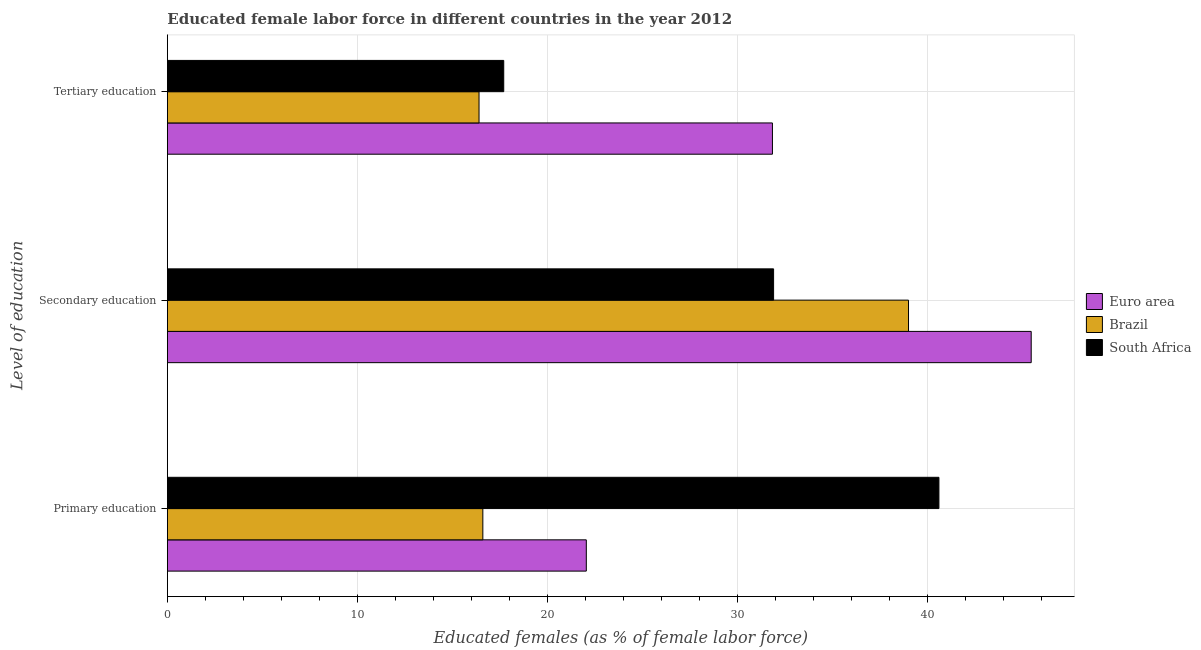How many different coloured bars are there?
Provide a short and direct response. 3. What is the label of the 2nd group of bars from the top?
Offer a very short reply. Secondary education. What is the percentage of female labor force who received tertiary education in South Africa?
Provide a short and direct response. 17.7. Across all countries, what is the maximum percentage of female labor force who received tertiary education?
Ensure brevity in your answer.  31.84. Across all countries, what is the minimum percentage of female labor force who received primary education?
Keep it short and to the point. 16.6. In which country was the percentage of female labor force who received primary education maximum?
Provide a succinct answer. South Africa. In which country was the percentage of female labor force who received primary education minimum?
Provide a short and direct response. Brazil. What is the total percentage of female labor force who received secondary education in the graph?
Your answer should be very brief. 116.36. What is the difference between the percentage of female labor force who received primary education in Brazil and that in Euro area?
Your answer should be compact. -5.44. What is the difference between the percentage of female labor force who received primary education in Euro area and the percentage of female labor force who received tertiary education in South Africa?
Provide a succinct answer. 4.34. What is the average percentage of female labor force who received secondary education per country?
Provide a succinct answer. 38.79. What is the difference between the percentage of female labor force who received secondary education and percentage of female labor force who received primary education in South Africa?
Keep it short and to the point. -8.7. What is the ratio of the percentage of female labor force who received tertiary education in Brazil to that in South Africa?
Offer a very short reply. 0.93. Is the percentage of female labor force who received primary education in South Africa less than that in Brazil?
Make the answer very short. No. What is the difference between the highest and the second highest percentage of female labor force who received tertiary education?
Make the answer very short. 14.14. What is the difference between the highest and the lowest percentage of female labor force who received secondary education?
Your answer should be compact. 13.56. In how many countries, is the percentage of female labor force who received secondary education greater than the average percentage of female labor force who received secondary education taken over all countries?
Offer a terse response. 2. Is the sum of the percentage of female labor force who received secondary education in Euro area and South Africa greater than the maximum percentage of female labor force who received tertiary education across all countries?
Provide a short and direct response. Yes. What does the 1st bar from the top in Tertiary education represents?
Keep it short and to the point. South Africa. What does the 3rd bar from the bottom in Tertiary education represents?
Your answer should be compact. South Africa. How many countries are there in the graph?
Offer a terse response. 3. Are the values on the major ticks of X-axis written in scientific E-notation?
Provide a short and direct response. No. Does the graph contain grids?
Offer a terse response. Yes. What is the title of the graph?
Make the answer very short. Educated female labor force in different countries in the year 2012. What is the label or title of the X-axis?
Keep it short and to the point. Educated females (as % of female labor force). What is the label or title of the Y-axis?
Provide a succinct answer. Level of education. What is the Educated females (as % of female labor force) in Euro area in Primary education?
Give a very brief answer. 22.04. What is the Educated females (as % of female labor force) in Brazil in Primary education?
Your answer should be very brief. 16.6. What is the Educated females (as % of female labor force) of South Africa in Primary education?
Provide a succinct answer. 40.6. What is the Educated females (as % of female labor force) of Euro area in Secondary education?
Give a very brief answer. 45.46. What is the Educated females (as % of female labor force) in Brazil in Secondary education?
Your answer should be very brief. 39. What is the Educated females (as % of female labor force) in South Africa in Secondary education?
Provide a succinct answer. 31.9. What is the Educated females (as % of female labor force) of Euro area in Tertiary education?
Offer a very short reply. 31.84. What is the Educated females (as % of female labor force) of Brazil in Tertiary education?
Provide a short and direct response. 16.4. What is the Educated females (as % of female labor force) of South Africa in Tertiary education?
Provide a short and direct response. 17.7. Across all Level of education, what is the maximum Educated females (as % of female labor force) of Euro area?
Your answer should be compact. 45.46. Across all Level of education, what is the maximum Educated females (as % of female labor force) of Brazil?
Your answer should be very brief. 39. Across all Level of education, what is the maximum Educated females (as % of female labor force) in South Africa?
Provide a short and direct response. 40.6. Across all Level of education, what is the minimum Educated females (as % of female labor force) of Euro area?
Your response must be concise. 22.04. Across all Level of education, what is the minimum Educated females (as % of female labor force) in Brazil?
Offer a terse response. 16.4. Across all Level of education, what is the minimum Educated females (as % of female labor force) of South Africa?
Give a very brief answer. 17.7. What is the total Educated females (as % of female labor force) in Euro area in the graph?
Offer a very short reply. 99.34. What is the total Educated females (as % of female labor force) of South Africa in the graph?
Make the answer very short. 90.2. What is the difference between the Educated females (as % of female labor force) of Euro area in Primary education and that in Secondary education?
Your answer should be very brief. -23.41. What is the difference between the Educated females (as % of female labor force) of Brazil in Primary education and that in Secondary education?
Your answer should be compact. -22.4. What is the difference between the Educated females (as % of female labor force) in Euro area in Primary education and that in Tertiary education?
Your response must be concise. -9.79. What is the difference between the Educated females (as % of female labor force) of South Africa in Primary education and that in Tertiary education?
Ensure brevity in your answer.  22.9. What is the difference between the Educated females (as % of female labor force) of Euro area in Secondary education and that in Tertiary education?
Your answer should be very brief. 13.62. What is the difference between the Educated females (as % of female labor force) of Brazil in Secondary education and that in Tertiary education?
Make the answer very short. 22.6. What is the difference between the Educated females (as % of female labor force) in Euro area in Primary education and the Educated females (as % of female labor force) in Brazil in Secondary education?
Give a very brief answer. -16.96. What is the difference between the Educated females (as % of female labor force) in Euro area in Primary education and the Educated females (as % of female labor force) in South Africa in Secondary education?
Make the answer very short. -9.86. What is the difference between the Educated females (as % of female labor force) in Brazil in Primary education and the Educated females (as % of female labor force) in South Africa in Secondary education?
Make the answer very short. -15.3. What is the difference between the Educated females (as % of female labor force) of Euro area in Primary education and the Educated females (as % of female labor force) of Brazil in Tertiary education?
Make the answer very short. 5.64. What is the difference between the Educated females (as % of female labor force) of Euro area in Primary education and the Educated females (as % of female labor force) of South Africa in Tertiary education?
Make the answer very short. 4.34. What is the difference between the Educated females (as % of female labor force) of Brazil in Primary education and the Educated females (as % of female labor force) of South Africa in Tertiary education?
Offer a terse response. -1.1. What is the difference between the Educated females (as % of female labor force) in Euro area in Secondary education and the Educated females (as % of female labor force) in Brazil in Tertiary education?
Give a very brief answer. 29.06. What is the difference between the Educated females (as % of female labor force) in Euro area in Secondary education and the Educated females (as % of female labor force) in South Africa in Tertiary education?
Provide a short and direct response. 27.76. What is the difference between the Educated females (as % of female labor force) in Brazil in Secondary education and the Educated females (as % of female labor force) in South Africa in Tertiary education?
Provide a succinct answer. 21.3. What is the average Educated females (as % of female labor force) of Euro area per Level of education?
Make the answer very short. 33.11. What is the average Educated females (as % of female labor force) in South Africa per Level of education?
Keep it short and to the point. 30.07. What is the difference between the Educated females (as % of female labor force) in Euro area and Educated females (as % of female labor force) in Brazil in Primary education?
Offer a terse response. 5.44. What is the difference between the Educated females (as % of female labor force) in Euro area and Educated females (as % of female labor force) in South Africa in Primary education?
Offer a terse response. -18.56. What is the difference between the Educated females (as % of female labor force) of Euro area and Educated females (as % of female labor force) of Brazil in Secondary education?
Offer a terse response. 6.46. What is the difference between the Educated females (as % of female labor force) of Euro area and Educated females (as % of female labor force) of South Africa in Secondary education?
Offer a very short reply. 13.56. What is the difference between the Educated females (as % of female labor force) in Brazil and Educated females (as % of female labor force) in South Africa in Secondary education?
Ensure brevity in your answer.  7.1. What is the difference between the Educated females (as % of female labor force) of Euro area and Educated females (as % of female labor force) of Brazil in Tertiary education?
Offer a very short reply. 15.44. What is the difference between the Educated females (as % of female labor force) of Euro area and Educated females (as % of female labor force) of South Africa in Tertiary education?
Offer a terse response. 14.14. What is the difference between the Educated females (as % of female labor force) of Brazil and Educated females (as % of female labor force) of South Africa in Tertiary education?
Your answer should be compact. -1.3. What is the ratio of the Educated females (as % of female labor force) of Euro area in Primary education to that in Secondary education?
Give a very brief answer. 0.48. What is the ratio of the Educated females (as % of female labor force) in Brazil in Primary education to that in Secondary education?
Provide a short and direct response. 0.43. What is the ratio of the Educated females (as % of female labor force) of South Africa in Primary education to that in Secondary education?
Your answer should be compact. 1.27. What is the ratio of the Educated females (as % of female labor force) in Euro area in Primary education to that in Tertiary education?
Your answer should be very brief. 0.69. What is the ratio of the Educated females (as % of female labor force) of Brazil in Primary education to that in Tertiary education?
Give a very brief answer. 1.01. What is the ratio of the Educated females (as % of female labor force) in South Africa in Primary education to that in Tertiary education?
Give a very brief answer. 2.29. What is the ratio of the Educated females (as % of female labor force) in Euro area in Secondary education to that in Tertiary education?
Keep it short and to the point. 1.43. What is the ratio of the Educated females (as % of female labor force) in Brazil in Secondary education to that in Tertiary education?
Offer a terse response. 2.38. What is the ratio of the Educated females (as % of female labor force) of South Africa in Secondary education to that in Tertiary education?
Offer a terse response. 1.8. What is the difference between the highest and the second highest Educated females (as % of female labor force) of Euro area?
Offer a terse response. 13.62. What is the difference between the highest and the second highest Educated females (as % of female labor force) of Brazil?
Make the answer very short. 22.4. What is the difference between the highest and the second highest Educated females (as % of female labor force) in South Africa?
Your answer should be compact. 8.7. What is the difference between the highest and the lowest Educated females (as % of female labor force) in Euro area?
Give a very brief answer. 23.41. What is the difference between the highest and the lowest Educated females (as % of female labor force) of Brazil?
Ensure brevity in your answer.  22.6. What is the difference between the highest and the lowest Educated females (as % of female labor force) in South Africa?
Your answer should be compact. 22.9. 